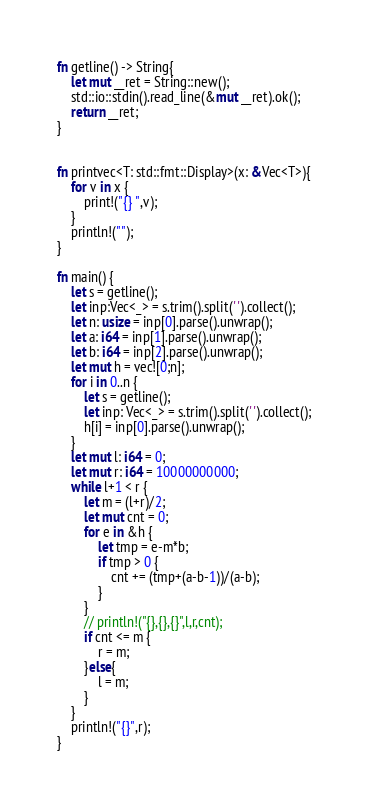Convert code to text. <code><loc_0><loc_0><loc_500><loc_500><_Rust_>
fn getline() -> String{
    let mut __ret = String::new();
    std::io::stdin().read_line(&mut __ret).ok();
    return __ret;
}


fn printvec<T: std::fmt::Display>(x: &Vec<T>){
    for v in x {
        print!("{} ",v);
    }
    println!("");
}

fn main() {
    let s = getline();
    let inp:Vec<_> = s.trim().split(' ').collect();
    let n: usize = inp[0].parse().unwrap();
    let a: i64 = inp[1].parse().unwrap();
    let b: i64 = inp[2].parse().unwrap();
    let mut h = vec![0;n];
    for i in 0..n {
        let s = getline();
        let inp: Vec<_> = s.trim().split(' ').collect();
        h[i] = inp[0].parse().unwrap();
    }
    let mut l: i64 = 0;
    let mut r: i64 = 10000000000;
    while l+1 < r {
        let m = (l+r)/2;
        let mut cnt = 0;
        for e in &h {
            let tmp = e-m*b;
            if tmp > 0 {
                cnt += (tmp+(a-b-1))/(a-b);
            }
        }
        // println!("{},{},{}",l,r,cnt);
        if cnt <= m {
            r = m;
        }else{
            l = m;
        }
    }
    println!("{}",r);
}
</code> 